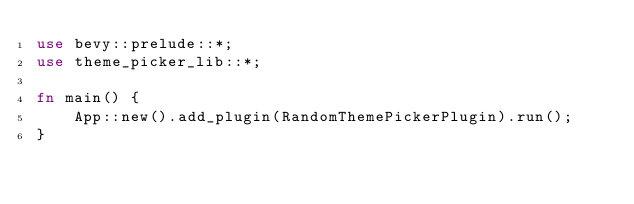<code> <loc_0><loc_0><loc_500><loc_500><_Rust_>use bevy::prelude::*;
use theme_picker_lib::*;

fn main() {
    App::new().add_plugin(RandomThemePickerPlugin).run();
}
</code> 